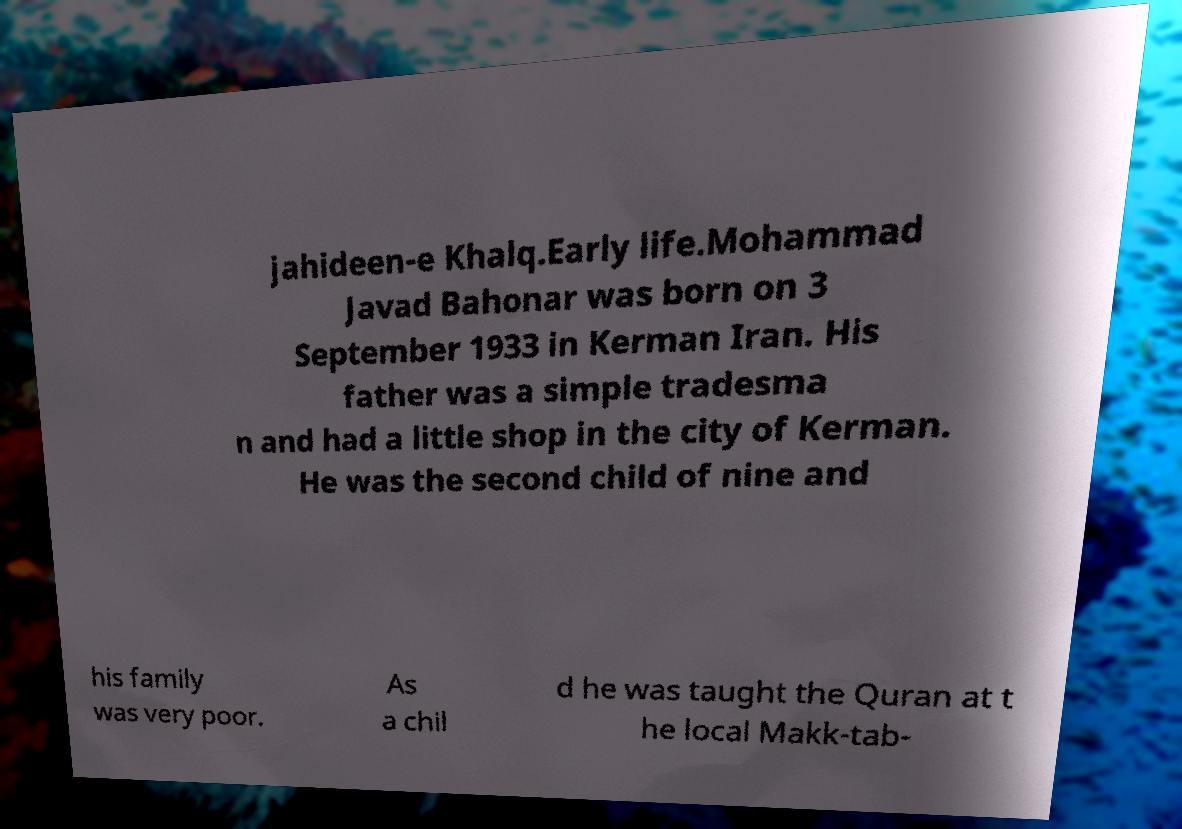Please identify and transcribe the text found in this image. jahideen-e Khalq.Early life.Mohammad Javad Bahonar was born on 3 September 1933 in Kerman Iran. His father was a simple tradesma n and had a little shop in the city of Kerman. He was the second child of nine and his family was very poor. As a chil d he was taught the Quran at t he local Makk-tab- 